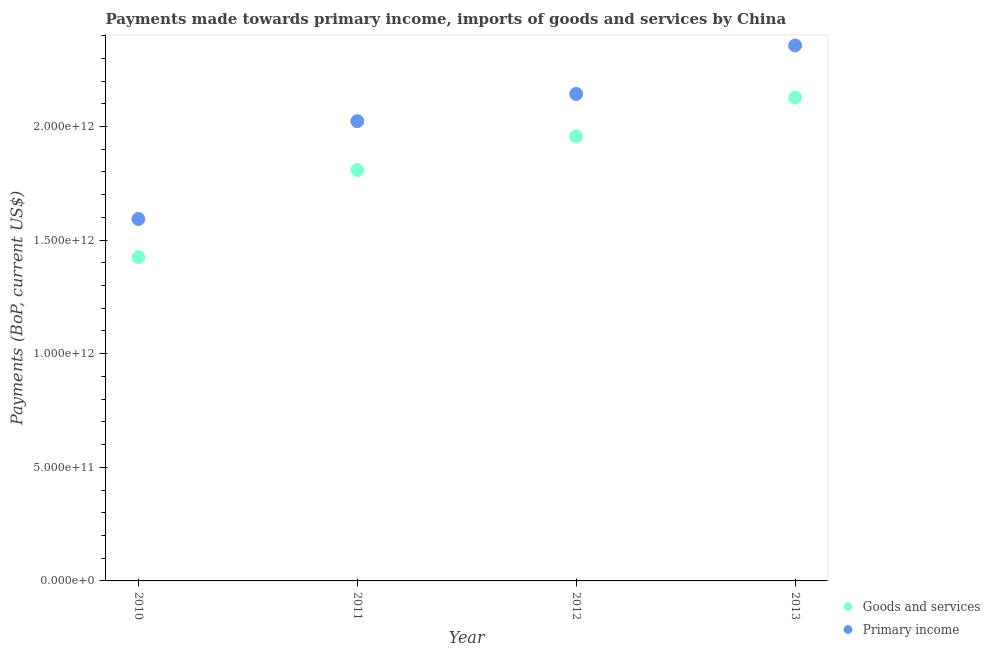What is the payments made towards primary income in 2011?
Your answer should be very brief. 2.02e+12. Across all years, what is the maximum payments made towards goods and services?
Provide a succinct answer. 2.13e+12. Across all years, what is the minimum payments made towards goods and services?
Ensure brevity in your answer.  1.42e+12. In which year was the payments made towards goods and services minimum?
Offer a terse response. 2010. What is the total payments made towards primary income in the graph?
Keep it short and to the point. 8.12e+12. What is the difference between the payments made towards primary income in 2010 and that in 2012?
Your response must be concise. -5.50e+11. What is the difference between the payments made towards primary income in 2012 and the payments made towards goods and services in 2013?
Make the answer very short. 1.61e+1. What is the average payments made towards goods and services per year?
Provide a succinct answer. 1.83e+12. In the year 2012, what is the difference between the payments made towards primary income and payments made towards goods and services?
Your response must be concise. 1.87e+11. In how many years, is the payments made towards primary income greater than 2000000000000 US$?
Offer a terse response. 3. What is the ratio of the payments made towards primary income in 2010 to that in 2012?
Provide a short and direct response. 0.74. What is the difference between the highest and the second highest payments made towards primary income?
Offer a terse response. 2.13e+11. What is the difference between the highest and the lowest payments made towards goods and services?
Keep it short and to the point. 7.03e+11. Is the sum of the payments made towards goods and services in 2010 and 2011 greater than the maximum payments made towards primary income across all years?
Your response must be concise. Yes. Is the payments made towards primary income strictly greater than the payments made towards goods and services over the years?
Keep it short and to the point. Yes. Is the payments made towards goods and services strictly less than the payments made towards primary income over the years?
Make the answer very short. Yes. How many dotlines are there?
Give a very brief answer. 2. What is the difference between two consecutive major ticks on the Y-axis?
Give a very brief answer. 5.00e+11. Are the values on the major ticks of Y-axis written in scientific E-notation?
Make the answer very short. Yes. Does the graph contain any zero values?
Your answer should be very brief. No. Where does the legend appear in the graph?
Your response must be concise. Bottom right. What is the title of the graph?
Your answer should be very brief. Payments made towards primary income, imports of goods and services by China. Does "Adolescent fertility rate" appear as one of the legend labels in the graph?
Offer a very short reply. No. What is the label or title of the X-axis?
Your response must be concise. Year. What is the label or title of the Y-axis?
Your answer should be very brief. Payments (BoP, current US$). What is the Payments (BoP, current US$) of Goods and services in 2010?
Keep it short and to the point. 1.42e+12. What is the Payments (BoP, current US$) in Primary income in 2010?
Your answer should be very brief. 1.59e+12. What is the Payments (BoP, current US$) of Goods and services in 2011?
Your answer should be compact. 1.81e+12. What is the Payments (BoP, current US$) of Primary income in 2011?
Your answer should be compact. 2.02e+12. What is the Payments (BoP, current US$) in Goods and services in 2012?
Offer a very short reply. 1.96e+12. What is the Payments (BoP, current US$) in Primary income in 2012?
Provide a short and direct response. 2.14e+12. What is the Payments (BoP, current US$) of Goods and services in 2013?
Ensure brevity in your answer.  2.13e+12. What is the Payments (BoP, current US$) of Primary income in 2013?
Offer a terse response. 2.36e+12. Across all years, what is the maximum Payments (BoP, current US$) of Goods and services?
Offer a terse response. 2.13e+12. Across all years, what is the maximum Payments (BoP, current US$) of Primary income?
Give a very brief answer. 2.36e+12. Across all years, what is the minimum Payments (BoP, current US$) of Goods and services?
Provide a short and direct response. 1.42e+12. Across all years, what is the minimum Payments (BoP, current US$) in Primary income?
Make the answer very short. 1.59e+12. What is the total Payments (BoP, current US$) of Goods and services in the graph?
Offer a terse response. 7.32e+12. What is the total Payments (BoP, current US$) of Primary income in the graph?
Your answer should be compact. 8.12e+12. What is the difference between the Payments (BoP, current US$) of Goods and services in 2010 and that in 2011?
Your answer should be very brief. -3.84e+11. What is the difference between the Payments (BoP, current US$) of Primary income in 2010 and that in 2011?
Make the answer very short. -4.30e+11. What is the difference between the Payments (BoP, current US$) in Goods and services in 2010 and that in 2012?
Keep it short and to the point. -5.32e+11. What is the difference between the Payments (BoP, current US$) of Primary income in 2010 and that in 2012?
Offer a terse response. -5.50e+11. What is the difference between the Payments (BoP, current US$) in Goods and services in 2010 and that in 2013?
Your answer should be very brief. -7.03e+11. What is the difference between the Payments (BoP, current US$) in Primary income in 2010 and that in 2013?
Your answer should be very brief. -7.64e+11. What is the difference between the Payments (BoP, current US$) of Goods and services in 2011 and that in 2012?
Give a very brief answer. -1.48e+11. What is the difference between the Payments (BoP, current US$) of Primary income in 2011 and that in 2012?
Ensure brevity in your answer.  -1.20e+11. What is the difference between the Payments (BoP, current US$) in Goods and services in 2011 and that in 2013?
Your response must be concise. -3.18e+11. What is the difference between the Payments (BoP, current US$) in Primary income in 2011 and that in 2013?
Offer a very short reply. -3.33e+11. What is the difference between the Payments (BoP, current US$) in Goods and services in 2012 and that in 2013?
Ensure brevity in your answer.  -1.71e+11. What is the difference between the Payments (BoP, current US$) of Primary income in 2012 and that in 2013?
Provide a short and direct response. -2.13e+11. What is the difference between the Payments (BoP, current US$) of Goods and services in 2010 and the Payments (BoP, current US$) of Primary income in 2011?
Keep it short and to the point. -5.99e+11. What is the difference between the Payments (BoP, current US$) of Goods and services in 2010 and the Payments (BoP, current US$) of Primary income in 2012?
Provide a short and direct response. -7.19e+11. What is the difference between the Payments (BoP, current US$) in Goods and services in 2010 and the Payments (BoP, current US$) in Primary income in 2013?
Provide a succinct answer. -9.32e+11. What is the difference between the Payments (BoP, current US$) in Goods and services in 2011 and the Payments (BoP, current US$) in Primary income in 2012?
Offer a terse response. -3.35e+11. What is the difference between the Payments (BoP, current US$) in Goods and services in 2011 and the Payments (BoP, current US$) in Primary income in 2013?
Provide a succinct answer. -5.48e+11. What is the difference between the Payments (BoP, current US$) in Goods and services in 2012 and the Payments (BoP, current US$) in Primary income in 2013?
Ensure brevity in your answer.  -4.00e+11. What is the average Payments (BoP, current US$) in Goods and services per year?
Your answer should be compact. 1.83e+12. What is the average Payments (BoP, current US$) in Primary income per year?
Make the answer very short. 2.03e+12. In the year 2010, what is the difference between the Payments (BoP, current US$) in Goods and services and Payments (BoP, current US$) in Primary income?
Your answer should be compact. -1.68e+11. In the year 2011, what is the difference between the Payments (BoP, current US$) of Goods and services and Payments (BoP, current US$) of Primary income?
Keep it short and to the point. -2.15e+11. In the year 2012, what is the difference between the Payments (BoP, current US$) in Goods and services and Payments (BoP, current US$) in Primary income?
Provide a short and direct response. -1.87e+11. In the year 2013, what is the difference between the Payments (BoP, current US$) in Goods and services and Payments (BoP, current US$) in Primary income?
Ensure brevity in your answer.  -2.29e+11. What is the ratio of the Payments (BoP, current US$) of Goods and services in 2010 to that in 2011?
Provide a succinct answer. 0.79. What is the ratio of the Payments (BoP, current US$) of Primary income in 2010 to that in 2011?
Offer a terse response. 0.79. What is the ratio of the Payments (BoP, current US$) in Goods and services in 2010 to that in 2012?
Offer a very short reply. 0.73. What is the ratio of the Payments (BoP, current US$) in Primary income in 2010 to that in 2012?
Offer a terse response. 0.74. What is the ratio of the Payments (BoP, current US$) in Goods and services in 2010 to that in 2013?
Provide a succinct answer. 0.67. What is the ratio of the Payments (BoP, current US$) of Primary income in 2010 to that in 2013?
Your answer should be very brief. 0.68. What is the ratio of the Payments (BoP, current US$) of Goods and services in 2011 to that in 2012?
Give a very brief answer. 0.92. What is the ratio of the Payments (BoP, current US$) in Primary income in 2011 to that in 2012?
Ensure brevity in your answer.  0.94. What is the ratio of the Payments (BoP, current US$) in Goods and services in 2011 to that in 2013?
Ensure brevity in your answer.  0.85. What is the ratio of the Payments (BoP, current US$) in Primary income in 2011 to that in 2013?
Ensure brevity in your answer.  0.86. What is the ratio of the Payments (BoP, current US$) of Goods and services in 2012 to that in 2013?
Ensure brevity in your answer.  0.92. What is the ratio of the Payments (BoP, current US$) in Primary income in 2012 to that in 2013?
Provide a succinct answer. 0.91. What is the difference between the highest and the second highest Payments (BoP, current US$) in Goods and services?
Offer a very short reply. 1.71e+11. What is the difference between the highest and the second highest Payments (BoP, current US$) of Primary income?
Keep it short and to the point. 2.13e+11. What is the difference between the highest and the lowest Payments (BoP, current US$) of Goods and services?
Your answer should be compact. 7.03e+11. What is the difference between the highest and the lowest Payments (BoP, current US$) in Primary income?
Provide a succinct answer. 7.64e+11. 